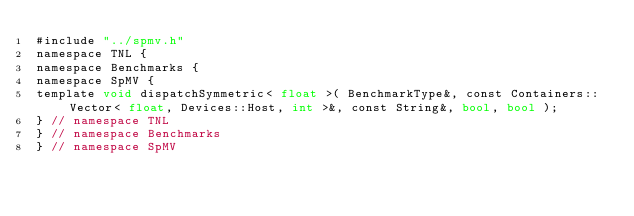<code> <loc_0><loc_0><loc_500><loc_500><_Cuda_>#include "../spmv.h"
namespace TNL {
namespace Benchmarks {
namespace SpMV {
template void dispatchSymmetric< float >( BenchmarkType&, const Containers::Vector< float, Devices::Host, int >&, const String&, bool, bool );
} // namespace TNL
} // namespace Benchmarks
} // namespace SpMV
</code> 